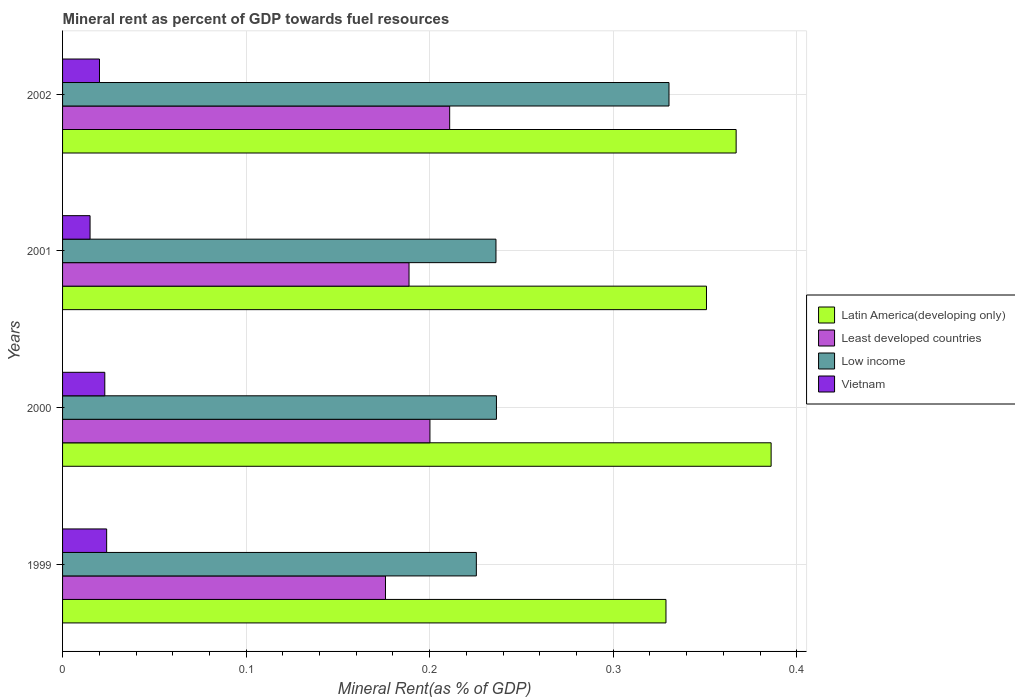Are the number of bars per tick equal to the number of legend labels?
Your response must be concise. Yes. What is the mineral rent in Latin America(developing only) in 2001?
Your response must be concise. 0.35. Across all years, what is the maximum mineral rent in Least developed countries?
Offer a terse response. 0.21. Across all years, what is the minimum mineral rent in Low income?
Offer a terse response. 0.23. In which year was the mineral rent in Least developed countries maximum?
Your answer should be compact. 2002. In which year was the mineral rent in Latin America(developing only) minimum?
Keep it short and to the point. 1999. What is the total mineral rent in Latin America(developing only) in the graph?
Make the answer very short. 1.43. What is the difference between the mineral rent in Latin America(developing only) in 2000 and that in 2002?
Offer a very short reply. 0.02. What is the difference between the mineral rent in Latin America(developing only) in 1999 and the mineral rent in Vietnam in 2001?
Ensure brevity in your answer.  0.31. What is the average mineral rent in Least developed countries per year?
Provide a succinct answer. 0.19. In the year 2002, what is the difference between the mineral rent in Least developed countries and mineral rent in Latin America(developing only)?
Offer a terse response. -0.16. What is the ratio of the mineral rent in Low income in 1999 to that in 2001?
Provide a short and direct response. 0.95. What is the difference between the highest and the second highest mineral rent in Latin America(developing only)?
Ensure brevity in your answer.  0.02. What is the difference between the highest and the lowest mineral rent in Vietnam?
Your answer should be very brief. 0.01. Is the sum of the mineral rent in Low income in 2001 and 2002 greater than the maximum mineral rent in Latin America(developing only) across all years?
Give a very brief answer. Yes. What does the 1st bar from the top in 2000 represents?
Make the answer very short. Vietnam. What does the 4th bar from the bottom in 2000 represents?
Keep it short and to the point. Vietnam. Is it the case that in every year, the sum of the mineral rent in Latin America(developing only) and mineral rent in Least developed countries is greater than the mineral rent in Low income?
Ensure brevity in your answer.  Yes. What is the title of the graph?
Ensure brevity in your answer.  Mineral rent as percent of GDP towards fuel resources. What is the label or title of the X-axis?
Offer a very short reply. Mineral Rent(as % of GDP). What is the label or title of the Y-axis?
Your response must be concise. Years. What is the Mineral Rent(as % of GDP) of Latin America(developing only) in 1999?
Give a very brief answer. 0.33. What is the Mineral Rent(as % of GDP) in Least developed countries in 1999?
Offer a very short reply. 0.18. What is the Mineral Rent(as % of GDP) in Low income in 1999?
Give a very brief answer. 0.23. What is the Mineral Rent(as % of GDP) in Vietnam in 1999?
Provide a succinct answer. 0.02. What is the Mineral Rent(as % of GDP) of Latin America(developing only) in 2000?
Your response must be concise. 0.39. What is the Mineral Rent(as % of GDP) in Least developed countries in 2000?
Your answer should be very brief. 0.2. What is the Mineral Rent(as % of GDP) in Low income in 2000?
Ensure brevity in your answer.  0.24. What is the Mineral Rent(as % of GDP) in Vietnam in 2000?
Offer a very short reply. 0.02. What is the Mineral Rent(as % of GDP) of Latin America(developing only) in 2001?
Keep it short and to the point. 0.35. What is the Mineral Rent(as % of GDP) of Least developed countries in 2001?
Your answer should be very brief. 0.19. What is the Mineral Rent(as % of GDP) of Low income in 2001?
Offer a very short reply. 0.24. What is the Mineral Rent(as % of GDP) in Vietnam in 2001?
Offer a very short reply. 0.01. What is the Mineral Rent(as % of GDP) in Latin America(developing only) in 2002?
Offer a very short reply. 0.37. What is the Mineral Rent(as % of GDP) of Least developed countries in 2002?
Give a very brief answer. 0.21. What is the Mineral Rent(as % of GDP) of Low income in 2002?
Your response must be concise. 0.33. What is the Mineral Rent(as % of GDP) in Vietnam in 2002?
Make the answer very short. 0.02. Across all years, what is the maximum Mineral Rent(as % of GDP) of Latin America(developing only)?
Your answer should be very brief. 0.39. Across all years, what is the maximum Mineral Rent(as % of GDP) of Least developed countries?
Ensure brevity in your answer.  0.21. Across all years, what is the maximum Mineral Rent(as % of GDP) of Low income?
Ensure brevity in your answer.  0.33. Across all years, what is the maximum Mineral Rent(as % of GDP) in Vietnam?
Your response must be concise. 0.02. Across all years, what is the minimum Mineral Rent(as % of GDP) of Latin America(developing only)?
Provide a short and direct response. 0.33. Across all years, what is the minimum Mineral Rent(as % of GDP) of Least developed countries?
Ensure brevity in your answer.  0.18. Across all years, what is the minimum Mineral Rent(as % of GDP) in Low income?
Make the answer very short. 0.23. Across all years, what is the minimum Mineral Rent(as % of GDP) of Vietnam?
Make the answer very short. 0.01. What is the total Mineral Rent(as % of GDP) of Latin America(developing only) in the graph?
Give a very brief answer. 1.43. What is the total Mineral Rent(as % of GDP) of Least developed countries in the graph?
Offer a terse response. 0.78. What is the total Mineral Rent(as % of GDP) in Low income in the graph?
Your response must be concise. 1.03. What is the total Mineral Rent(as % of GDP) of Vietnam in the graph?
Your answer should be compact. 0.08. What is the difference between the Mineral Rent(as % of GDP) in Latin America(developing only) in 1999 and that in 2000?
Make the answer very short. -0.06. What is the difference between the Mineral Rent(as % of GDP) of Least developed countries in 1999 and that in 2000?
Give a very brief answer. -0.02. What is the difference between the Mineral Rent(as % of GDP) in Low income in 1999 and that in 2000?
Offer a very short reply. -0.01. What is the difference between the Mineral Rent(as % of GDP) of Vietnam in 1999 and that in 2000?
Your response must be concise. 0. What is the difference between the Mineral Rent(as % of GDP) in Latin America(developing only) in 1999 and that in 2001?
Keep it short and to the point. -0.02. What is the difference between the Mineral Rent(as % of GDP) in Least developed countries in 1999 and that in 2001?
Provide a short and direct response. -0.01. What is the difference between the Mineral Rent(as % of GDP) of Low income in 1999 and that in 2001?
Your response must be concise. -0.01. What is the difference between the Mineral Rent(as % of GDP) in Vietnam in 1999 and that in 2001?
Offer a very short reply. 0.01. What is the difference between the Mineral Rent(as % of GDP) in Latin America(developing only) in 1999 and that in 2002?
Offer a very short reply. -0.04. What is the difference between the Mineral Rent(as % of GDP) in Least developed countries in 1999 and that in 2002?
Give a very brief answer. -0.04. What is the difference between the Mineral Rent(as % of GDP) of Low income in 1999 and that in 2002?
Offer a very short reply. -0.1. What is the difference between the Mineral Rent(as % of GDP) in Vietnam in 1999 and that in 2002?
Your answer should be very brief. 0. What is the difference between the Mineral Rent(as % of GDP) in Latin America(developing only) in 2000 and that in 2001?
Offer a terse response. 0.04. What is the difference between the Mineral Rent(as % of GDP) in Least developed countries in 2000 and that in 2001?
Offer a very short reply. 0.01. What is the difference between the Mineral Rent(as % of GDP) of Low income in 2000 and that in 2001?
Make the answer very short. 0. What is the difference between the Mineral Rent(as % of GDP) in Vietnam in 2000 and that in 2001?
Your response must be concise. 0.01. What is the difference between the Mineral Rent(as % of GDP) in Latin America(developing only) in 2000 and that in 2002?
Provide a succinct answer. 0.02. What is the difference between the Mineral Rent(as % of GDP) of Least developed countries in 2000 and that in 2002?
Give a very brief answer. -0.01. What is the difference between the Mineral Rent(as % of GDP) in Low income in 2000 and that in 2002?
Provide a short and direct response. -0.09. What is the difference between the Mineral Rent(as % of GDP) in Vietnam in 2000 and that in 2002?
Give a very brief answer. 0. What is the difference between the Mineral Rent(as % of GDP) in Latin America(developing only) in 2001 and that in 2002?
Ensure brevity in your answer.  -0.02. What is the difference between the Mineral Rent(as % of GDP) in Least developed countries in 2001 and that in 2002?
Offer a very short reply. -0.02. What is the difference between the Mineral Rent(as % of GDP) in Low income in 2001 and that in 2002?
Offer a terse response. -0.09. What is the difference between the Mineral Rent(as % of GDP) of Vietnam in 2001 and that in 2002?
Make the answer very short. -0.01. What is the difference between the Mineral Rent(as % of GDP) in Latin America(developing only) in 1999 and the Mineral Rent(as % of GDP) in Least developed countries in 2000?
Provide a succinct answer. 0.13. What is the difference between the Mineral Rent(as % of GDP) in Latin America(developing only) in 1999 and the Mineral Rent(as % of GDP) in Low income in 2000?
Your answer should be very brief. 0.09. What is the difference between the Mineral Rent(as % of GDP) of Latin America(developing only) in 1999 and the Mineral Rent(as % of GDP) of Vietnam in 2000?
Your answer should be very brief. 0.31. What is the difference between the Mineral Rent(as % of GDP) of Least developed countries in 1999 and the Mineral Rent(as % of GDP) of Low income in 2000?
Ensure brevity in your answer.  -0.06. What is the difference between the Mineral Rent(as % of GDP) of Least developed countries in 1999 and the Mineral Rent(as % of GDP) of Vietnam in 2000?
Ensure brevity in your answer.  0.15. What is the difference between the Mineral Rent(as % of GDP) of Low income in 1999 and the Mineral Rent(as % of GDP) of Vietnam in 2000?
Your response must be concise. 0.2. What is the difference between the Mineral Rent(as % of GDP) of Latin America(developing only) in 1999 and the Mineral Rent(as % of GDP) of Least developed countries in 2001?
Ensure brevity in your answer.  0.14. What is the difference between the Mineral Rent(as % of GDP) in Latin America(developing only) in 1999 and the Mineral Rent(as % of GDP) in Low income in 2001?
Your answer should be very brief. 0.09. What is the difference between the Mineral Rent(as % of GDP) in Latin America(developing only) in 1999 and the Mineral Rent(as % of GDP) in Vietnam in 2001?
Your answer should be very brief. 0.31. What is the difference between the Mineral Rent(as % of GDP) of Least developed countries in 1999 and the Mineral Rent(as % of GDP) of Low income in 2001?
Your answer should be very brief. -0.06. What is the difference between the Mineral Rent(as % of GDP) in Least developed countries in 1999 and the Mineral Rent(as % of GDP) in Vietnam in 2001?
Provide a short and direct response. 0.16. What is the difference between the Mineral Rent(as % of GDP) in Low income in 1999 and the Mineral Rent(as % of GDP) in Vietnam in 2001?
Ensure brevity in your answer.  0.21. What is the difference between the Mineral Rent(as % of GDP) in Latin America(developing only) in 1999 and the Mineral Rent(as % of GDP) in Least developed countries in 2002?
Provide a short and direct response. 0.12. What is the difference between the Mineral Rent(as % of GDP) in Latin America(developing only) in 1999 and the Mineral Rent(as % of GDP) in Low income in 2002?
Ensure brevity in your answer.  -0. What is the difference between the Mineral Rent(as % of GDP) of Latin America(developing only) in 1999 and the Mineral Rent(as % of GDP) of Vietnam in 2002?
Your answer should be compact. 0.31. What is the difference between the Mineral Rent(as % of GDP) in Least developed countries in 1999 and the Mineral Rent(as % of GDP) in Low income in 2002?
Your response must be concise. -0.15. What is the difference between the Mineral Rent(as % of GDP) of Least developed countries in 1999 and the Mineral Rent(as % of GDP) of Vietnam in 2002?
Offer a very short reply. 0.16. What is the difference between the Mineral Rent(as % of GDP) in Low income in 1999 and the Mineral Rent(as % of GDP) in Vietnam in 2002?
Ensure brevity in your answer.  0.21. What is the difference between the Mineral Rent(as % of GDP) of Latin America(developing only) in 2000 and the Mineral Rent(as % of GDP) of Least developed countries in 2001?
Ensure brevity in your answer.  0.2. What is the difference between the Mineral Rent(as % of GDP) of Latin America(developing only) in 2000 and the Mineral Rent(as % of GDP) of Low income in 2001?
Keep it short and to the point. 0.15. What is the difference between the Mineral Rent(as % of GDP) of Latin America(developing only) in 2000 and the Mineral Rent(as % of GDP) of Vietnam in 2001?
Ensure brevity in your answer.  0.37. What is the difference between the Mineral Rent(as % of GDP) of Least developed countries in 2000 and the Mineral Rent(as % of GDP) of Low income in 2001?
Your answer should be compact. -0.04. What is the difference between the Mineral Rent(as % of GDP) in Least developed countries in 2000 and the Mineral Rent(as % of GDP) in Vietnam in 2001?
Your answer should be compact. 0.19. What is the difference between the Mineral Rent(as % of GDP) in Low income in 2000 and the Mineral Rent(as % of GDP) in Vietnam in 2001?
Offer a very short reply. 0.22. What is the difference between the Mineral Rent(as % of GDP) in Latin America(developing only) in 2000 and the Mineral Rent(as % of GDP) in Least developed countries in 2002?
Make the answer very short. 0.18. What is the difference between the Mineral Rent(as % of GDP) of Latin America(developing only) in 2000 and the Mineral Rent(as % of GDP) of Low income in 2002?
Ensure brevity in your answer.  0.06. What is the difference between the Mineral Rent(as % of GDP) of Latin America(developing only) in 2000 and the Mineral Rent(as % of GDP) of Vietnam in 2002?
Provide a short and direct response. 0.37. What is the difference between the Mineral Rent(as % of GDP) in Least developed countries in 2000 and the Mineral Rent(as % of GDP) in Low income in 2002?
Your response must be concise. -0.13. What is the difference between the Mineral Rent(as % of GDP) in Least developed countries in 2000 and the Mineral Rent(as % of GDP) in Vietnam in 2002?
Ensure brevity in your answer.  0.18. What is the difference between the Mineral Rent(as % of GDP) in Low income in 2000 and the Mineral Rent(as % of GDP) in Vietnam in 2002?
Provide a short and direct response. 0.22. What is the difference between the Mineral Rent(as % of GDP) of Latin America(developing only) in 2001 and the Mineral Rent(as % of GDP) of Least developed countries in 2002?
Your response must be concise. 0.14. What is the difference between the Mineral Rent(as % of GDP) in Latin America(developing only) in 2001 and the Mineral Rent(as % of GDP) in Low income in 2002?
Keep it short and to the point. 0.02. What is the difference between the Mineral Rent(as % of GDP) of Latin America(developing only) in 2001 and the Mineral Rent(as % of GDP) of Vietnam in 2002?
Give a very brief answer. 0.33. What is the difference between the Mineral Rent(as % of GDP) in Least developed countries in 2001 and the Mineral Rent(as % of GDP) in Low income in 2002?
Provide a succinct answer. -0.14. What is the difference between the Mineral Rent(as % of GDP) in Least developed countries in 2001 and the Mineral Rent(as % of GDP) in Vietnam in 2002?
Your answer should be very brief. 0.17. What is the difference between the Mineral Rent(as % of GDP) of Low income in 2001 and the Mineral Rent(as % of GDP) of Vietnam in 2002?
Keep it short and to the point. 0.22. What is the average Mineral Rent(as % of GDP) in Latin America(developing only) per year?
Provide a short and direct response. 0.36. What is the average Mineral Rent(as % of GDP) of Least developed countries per year?
Provide a succinct answer. 0.19. What is the average Mineral Rent(as % of GDP) in Low income per year?
Your answer should be compact. 0.26. What is the average Mineral Rent(as % of GDP) in Vietnam per year?
Make the answer very short. 0.02. In the year 1999, what is the difference between the Mineral Rent(as % of GDP) in Latin America(developing only) and Mineral Rent(as % of GDP) in Least developed countries?
Keep it short and to the point. 0.15. In the year 1999, what is the difference between the Mineral Rent(as % of GDP) in Latin America(developing only) and Mineral Rent(as % of GDP) in Low income?
Offer a terse response. 0.1. In the year 1999, what is the difference between the Mineral Rent(as % of GDP) of Latin America(developing only) and Mineral Rent(as % of GDP) of Vietnam?
Offer a terse response. 0.3. In the year 1999, what is the difference between the Mineral Rent(as % of GDP) of Least developed countries and Mineral Rent(as % of GDP) of Low income?
Provide a short and direct response. -0.05. In the year 1999, what is the difference between the Mineral Rent(as % of GDP) of Least developed countries and Mineral Rent(as % of GDP) of Vietnam?
Your answer should be compact. 0.15. In the year 1999, what is the difference between the Mineral Rent(as % of GDP) in Low income and Mineral Rent(as % of GDP) in Vietnam?
Your answer should be compact. 0.2. In the year 2000, what is the difference between the Mineral Rent(as % of GDP) in Latin America(developing only) and Mineral Rent(as % of GDP) in Least developed countries?
Provide a succinct answer. 0.19. In the year 2000, what is the difference between the Mineral Rent(as % of GDP) in Latin America(developing only) and Mineral Rent(as % of GDP) in Low income?
Provide a short and direct response. 0.15. In the year 2000, what is the difference between the Mineral Rent(as % of GDP) of Latin America(developing only) and Mineral Rent(as % of GDP) of Vietnam?
Provide a short and direct response. 0.36. In the year 2000, what is the difference between the Mineral Rent(as % of GDP) of Least developed countries and Mineral Rent(as % of GDP) of Low income?
Your answer should be compact. -0.04. In the year 2000, what is the difference between the Mineral Rent(as % of GDP) of Least developed countries and Mineral Rent(as % of GDP) of Vietnam?
Your answer should be compact. 0.18. In the year 2000, what is the difference between the Mineral Rent(as % of GDP) in Low income and Mineral Rent(as % of GDP) in Vietnam?
Provide a succinct answer. 0.21. In the year 2001, what is the difference between the Mineral Rent(as % of GDP) in Latin America(developing only) and Mineral Rent(as % of GDP) in Least developed countries?
Offer a terse response. 0.16. In the year 2001, what is the difference between the Mineral Rent(as % of GDP) of Latin America(developing only) and Mineral Rent(as % of GDP) of Low income?
Your answer should be compact. 0.11. In the year 2001, what is the difference between the Mineral Rent(as % of GDP) in Latin America(developing only) and Mineral Rent(as % of GDP) in Vietnam?
Ensure brevity in your answer.  0.34. In the year 2001, what is the difference between the Mineral Rent(as % of GDP) of Least developed countries and Mineral Rent(as % of GDP) of Low income?
Keep it short and to the point. -0.05. In the year 2001, what is the difference between the Mineral Rent(as % of GDP) of Least developed countries and Mineral Rent(as % of GDP) of Vietnam?
Give a very brief answer. 0.17. In the year 2001, what is the difference between the Mineral Rent(as % of GDP) of Low income and Mineral Rent(as % of GDP) of Vietnam?
Provide a short and direct response. 0.22. In the year 2002, what is the difference between the Mineral Rent(as % of GDP) in Latin America(developing only) and Mineral Rent(as % of GDP) in Least developed countries?
Provide a short and direct response. 0.16. In the year 2002, what is the difference between the Mineral Rent(as % of GDP) of Latin America(developing only) and Mineral Rent(as % of GDP) of Low income?
Give a very brief answer. 0.04. In the year 2002, what is the difference between the Mineral Rent(as % of GDP) of Latin America(developing only) and Mineral Rent(as % of GDP) of Vietnam?
Your answer should be very brief. 0.35. In the year 2002, what is the difference between the Mineral Rent(as % of GDP) of Least developed countries and Mineral Rent(as % of GDP) of Low income?
Provide a succinct answer. -0.12. In the year 2002, what is the difference between the Mineral Rent(as % of GDP) in Least developed countries and Mineral Rent(as % of GDP) in Vietnam?
Provide a short and direct response. 0.19. In the year 2002, what is the difference between the Mineral Rent(as % of GDP) of Low income and Mineral Rent(as % of GDP) of Vietnam?
Your answer should be compact. 0.31. What is the ratio of the Mineral Rent(as % of GDP) in Latin America(developing only) in 1999 to that in 2000?
Keep it short and to the point. 0.85. What is the ratio of the Mineral Rent(as % of GDP) in Least developed countries in 1999 to that in 2000?
Keep it short and to the point. 0.88. What is the ratio of the Mineral Rent(as % of GDP) of Low income in 1999 to that in 2000?
Your answer should be very brief. 0.95. What is the ratio of the Mineral Rent(as % of GDP) in Vietnam in 1999 to that in 2000?
Give a very brief answer. 1.04. What is the ratio of the Mineral Rent(as % of GDP) in Latin America(developing only) in 1999 to that in 2001?
Provide a short and direct response. 0.94. What is the ratio of the Mineral Rent(as % of GDP) in Least developed countries in 1999 to that in 2001?
Offer a very short reply. 0.93. What is the ratio of the Mineral Rent(as % of GDP) in Low income in 1999 to that in 2001?
Offer a very short reply. 0.95. What is the ratio of the Mineral Rent(as % of GDP) of Vietnam in 1999 to that in 2001?
Provide a short and direct response. 1.6. What is the ratio of the Mineral Rent(as % of GDP) in Latin America(developing only) in 1999 to that in 2002?
Your answer should be compact. 0.9. What is the ratio of the Mineral Rent(as % of GDP) of Least developed countries in 1999 to that in 2002?
Give a very brief answer. 0.83. What is the ratio of the Mineral Rent(as % of GDP) of Low income in 1999 to that in 2002?
Make the answer very short. 0.68. What is the ratio of the Mineral Rent(as % of GDP) in Vietnam in 1999 to that in 2002?
Make the answer very short. 1.19. What is the ratio of the Mineral Rent(as % of GDP) in Latin America(developing only) in 2000 to that in 2001?
Make the answer very short. 1.1. What is the ratio of the Mineral Rent(as % of GDP) of Least developed countries in 2000 to that in 2001?
Provide a succinct answer. 1.06. What is the ratio of the Mineral Rent(as % of GDP) in Low income in 2000 to that in 2001?
Give a very brief answer. 1. What is the ratio of the Mineral Rent(as % of GDP) in Vietnam in 2000 to that in 2001?
Provide a short and direct response. 1.54. What is the ratio of the Mineral Rent(as % of GDP) in Latin America(developing only) in 2000 to that in 2002?
Your answer should be very brief. 1.05. What is the ratio of the Mineral Rent(as % of GDP) in Least developed countries in 2000 to that in 2002?
Your answer should be very brief. 0.95. What is the ratio of the Mineral Rent(as % of GDP) of Low income in 2000 to that in 2002?
Provide a short and direct response. 0.72. What is the ratio of the Mineral Rent(as % of GDP) of Vietnam in 2000 to that in 2002?
Your response must be concise. 1.14. What is the ratio of the Mineral Rent(as % of GDP) of Latin America(developing only) in 2001 to that in 2002?
Your response must be concise. 0.96. What is the ratio of the Mineral Rent(as % of GDP) of Least developed countries in 2001 to that in 2002?
Provide a succinct answer. 0.9. What is the ratio of the Mineral Rent(as % of GDP) in Low income in 2001 to that in 2002?
Your answer should be very brief. 0.71. What is the ratio of the Mineral Rent(as % of GDP) of Vietnam in 2001 to that in 2002?
Ensure brevity in your answer.  0.74. What is the difference between the highest and the second highest Mineral Rent(as % of GDP) of Latin America(developing only)?
Make the answer very short. 0.02. What is the difference between the highest and the second highest Mineral Rent(as % of GDP) in Least developed countries?
Your answer should be compact. 0.01. What is the difference between the highest and the second highest Mineral Rent(as % of GDP) in Low income?
Make the answer very short. 0.09. What is the difference between the highest and the second highest Mineral Rent(as % of GDP) of Vietnam?
Offer a terse response. 0. What is the difference between the highest and the lowest Mineral Rent(as % of GDP) in Latin America(developing only)?
Keep it short and to the point. 0.06. What is the difference between the highest and the lowest Mineral Rent(as % of GDP) of Least developed countries?
Give a very brief answer. 0.04. What is the difference between the highest and the lowest Mineral Rent(as % of GDP) of Low income?
Give a very brief answer. 0.1. What is the difference between the highest and the lowest Mineral Rent(as % of GDP) of Vietnam?
Your response must be concise. 0.01. 